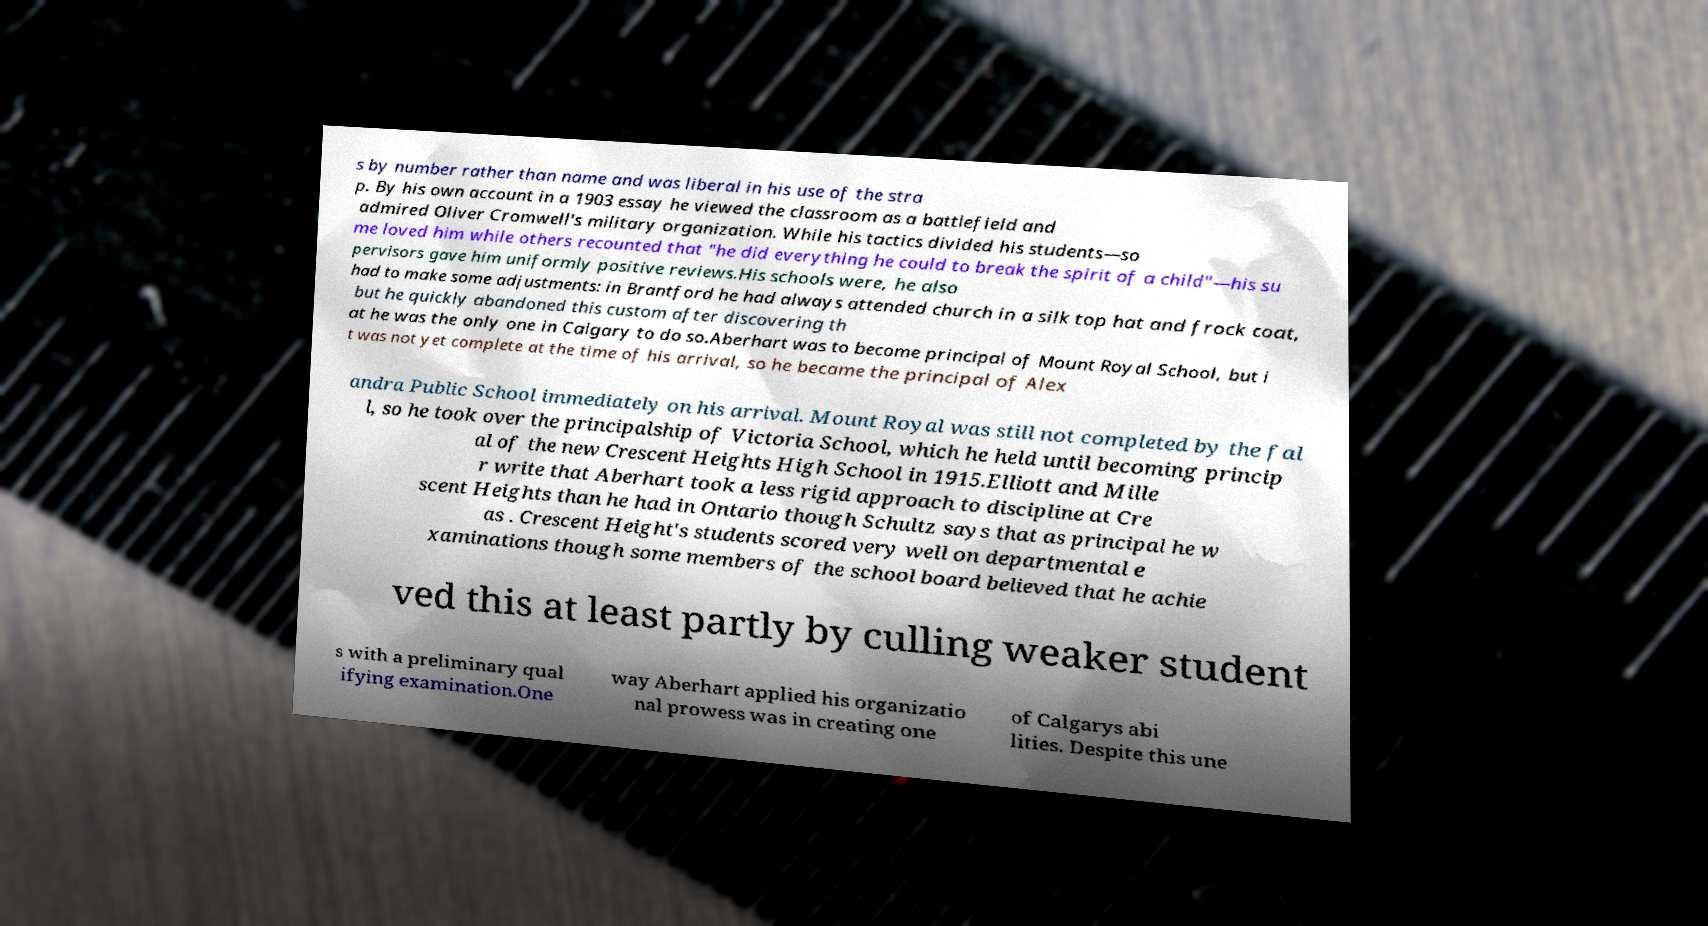There's text embedded in this image that I need extracted. Can you transcribe it verbatim? s by number rather than name and was liberal in his use of the stra p. By his own account in a 1903 essay he viewed the classroom as a battlefield and admired Oliver Cromwell's military organization. While his tactics divided his students—so me loved him while others recounted that "he did everything he could to break the spirit of a child"—his su pervisors gave him uniformly positive reviews.His schools were, he also had to make some adjustments: in Brantford he had always attended church in a silk top hat and frock coat, but he quickly abandoned this custom after discovering th at he was the only one in Calgary to do so.Aberhart was to become principal of Mount Royal School, but i t was not yet complete at the time of his arrival, so he became the principal of Alex andra Public School immediately on his arrival. Mount Royal was still not completed by the fal l, so he took over the principalship of Victoria School, which he held until becoming princip al of the new Crescent Heights High School in 1915.Elliott and Mille r write that Aberhart took a less rigid approach to discipline at Cre scent Heights than he had in Ontario though Schultz says that as principal he w as . Crescent Height's students scored very well on departmental e xaminations though some members of the school board believed that he achie ved this at least partly by culling weaker student s with a preliminary qual ifying examination.One way Aberhart applied his organizatio nal prowess was in creating one of Calgarys abi lities. Despite this une 